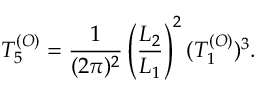<formula> <loc_0><loc_0><loc_500><loc_500>T _ { 5 } ^ { ( O ) } = { \frac { 1 } { ( 2 \pi ) ^ { 2 } } } \left ( { \frac { L _ { 2 } } { L _ { 1 } } } \right ) ^ { 2 } ( T _ { 1 } ^ { ( O ) } ) ^ { 3 } .</formula> 